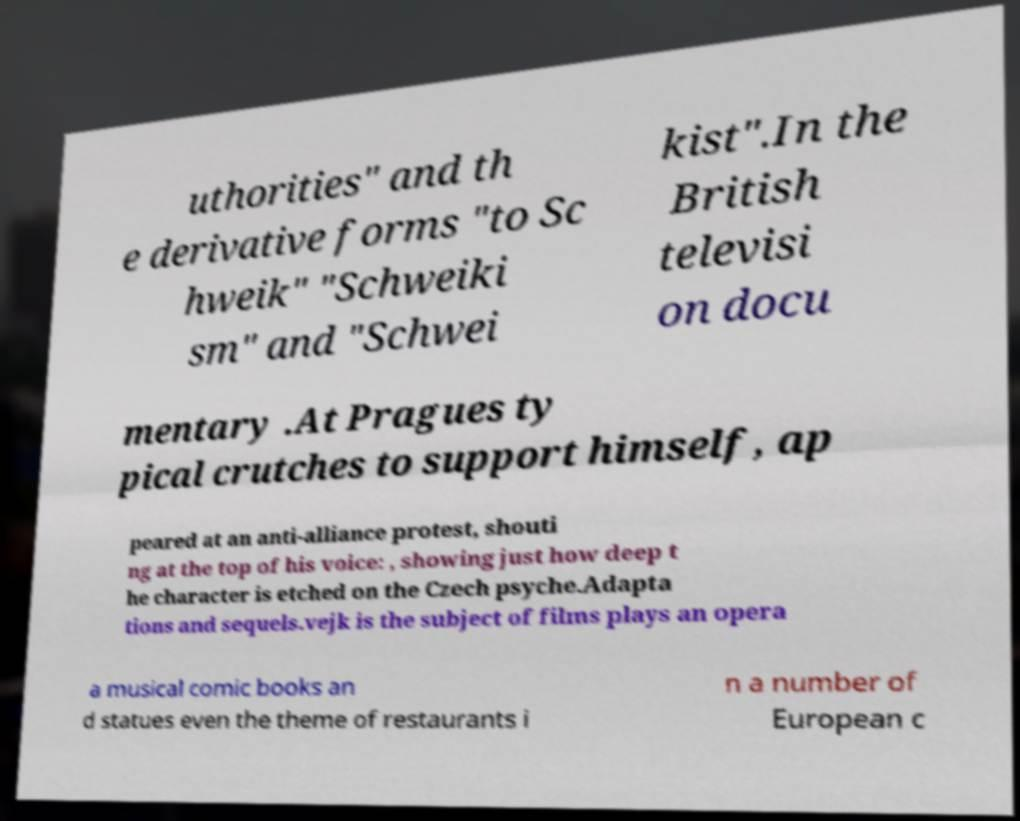For documentation purposes, I need the text within this image transcribed. Could you provide that? uthorities" and th e derivative forms "to Sc hweik" "Schweiki sm" and "Schwei kist".In the British televisi on docu mentary .At Pragues ty pical crutches to support himself, ap peared at an anti-alliance protest, shouti ng at the top of his voice: , showing just how deep t he character is etched on the Czech psyche.Adapta tions and sequels.vejk is the subject of films plays an opera a musical comic books an d statues even the theme of restaurants i n a number of European c 